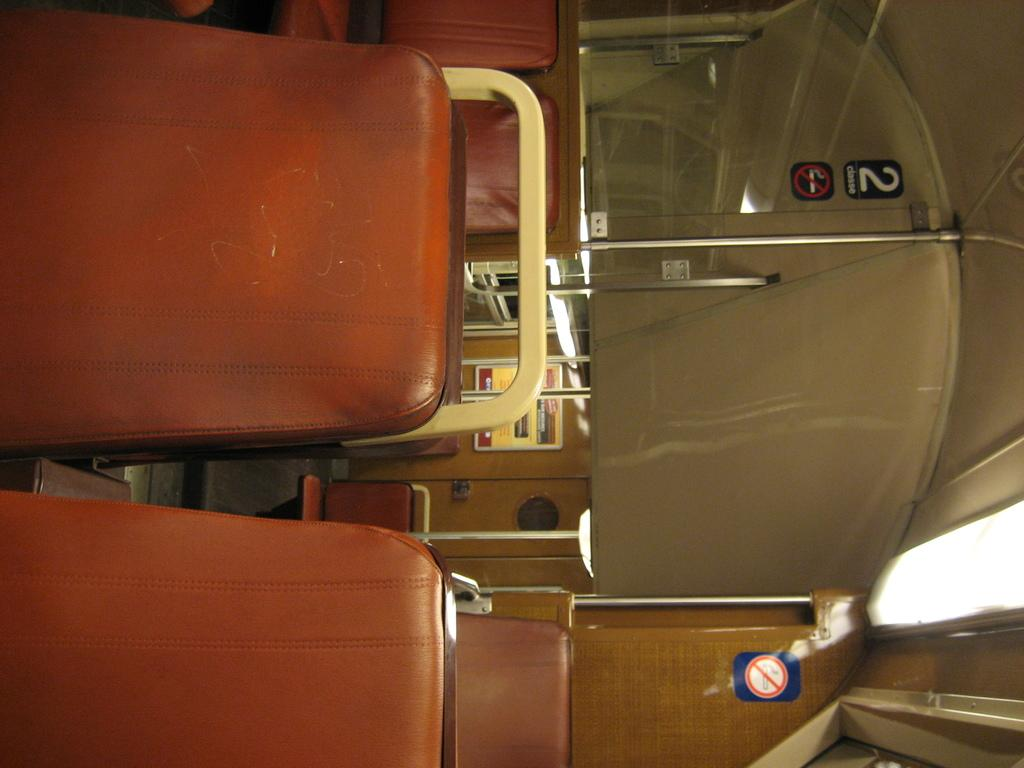What type of furniture is visible in the image? There are seats in the image. What is the color of the seats? The seats are brown in color. What can be seen in the background of the image? There is a wooden wall in the background of the image. What is attached to the wooden wall? There are boards on the wooden wall. What is on the glass in the image? There are stickers on the glass in the image. What type of noise can be heard coming from the friends in the image? There are no friends present in the image, so it is not possible to determine what noise might be heard. 